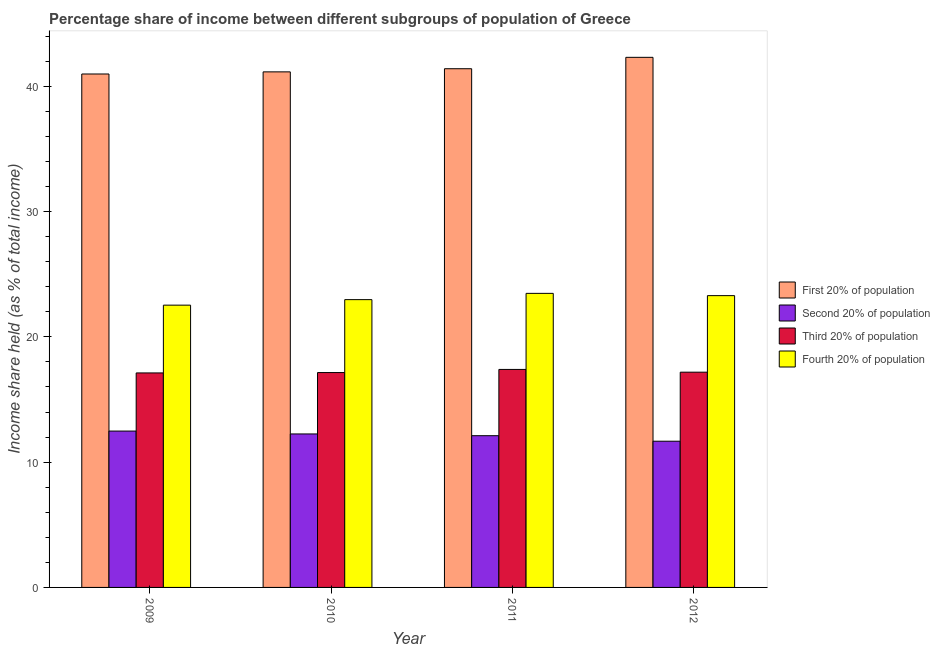How many bars are there on the 2nd tick from the left?
Your answer should be very brief. 4. How many bars are there on the 4th tick from the right?
Ensure brevity in your answer.  4. In how many cases, is the number of bars for a given year not equal to the number of legend labels?
Your answer should be compact. 0. What is the share of the income held by first 20% of the population in 2009?
Provide a succinct answer. 40.98. Across all years, what is the maximum share of the income held by fourth 20% of the population?
Offer a terse response. 23.47. Across all years, what is the minimum share of the income held by fourth 20% of the population?
Ensure brevity in your answer.  22.53. In which year was the share of the income held by third 20% of the population maximum?
Your answer should be compact. 2011. In which year was the share of the income held by fourth 20% of the population minimum?
Your response must be concise. 2009. What is the total share of the income held by fourth 20% of the population in the graph?
Make the answer very short. 92.26. What is the difference between the share of the income held by third 20% of the population in 2011 and that in 2012?
Provide a short and direct response. 0.22. What is the difference between the share of the income held by second 20% of the population in 2012 and the share of the income held by fourth 20% of the population in 2010?
Make the answer very short. -0.58. What is the average share of the income held by third 20% of the population per year?
Your response must be concise. 17.21. In the year 2011, what is the difference between the share of the income held by third 20% of the population and share of the income held by second 20% of the population?
Ensure brevity in your answer.  0. In how many years, is the share of the income held by second 20% of the population greater than 26 %?
Keep it short and to the point. 0. What is the ratio of the share of the income held by first 20% of the population in 2010 to that in 2012?
Provide a short and direct response. 0.97. What is the difference between the highest and the second highest share of the income held by second 20% of the population?
Keep it short and to the point. 0.23. What is the difference between the highest and the lowest share of the income held by third 20% of the population?
Keep it short and to the point. 0.28. Is it the case that in every year, the sum of the share of the income held by third 20% of the population and share of the income held by fourth 20% of the population is greater than the sum of share of the income held by first 20% of the population and share of the income held by second 20% of the population?
Give a very brief answer. No. What does the 3rd bar from the left in 2009 represents?
Make the answer very short. Third 20% of population. What does the 3rd bar from the right in 2012 represents?
Offer a terse response. Second 20% of population. How many bars are there?
Give a very brief answer. 16. How many years are there in the graph?
Give a very brief answer. 4. What is the difference between two consecutive major ticks on the Y-axis?
Offer a very short reply. 10. Are the values on the major ticks of Y-axis written in scientific E-notation?
Offer a very short reply. No. Where does the legend appear in the graph?
Make the answer very short. Center right. What is the title of the graph?
Give a very brief answer. Percentage share of income between different subgroups of population of Greece. Does "International Development Association" appear as one of the legend labels in the graph?
Offer a very short reply. No. What is the label or title of the X-axis?
Make the answer very short. Year. What is the label or title of the Y-axis?
Give a very brief answer. Income share held (as % of total income). What is the Income share held (as % of total income) in First 20% of population in 2009?
Provide a succinct answer. 40.98. What is the Income share held (as % of total income) of Second 20% of population in 2009?
Your response must be concise. 12.48. What is the Income share held (as % of total income) in Third 20% of population in 2009?
Give a very brief answer. 17.12. What is the Income share held (as % of total income) of Fourth 20% of population in 2009?
Give a very brief answer. 22.53. What is the Income share held (as % of total income) of First 20% of population in 2010?
Offer a very short reply. 41.15. What is the Income share held (as % of total income) in Second 20% of population in 2010?
Provide a succinct answer. 12.25. What is the Income share held (as % of total income) in Third 20% of population in 2010?
Ensure brevity in your answer.  17.15. What is the Income share held (as % of total income) of Fourth 20% of population in 2010?
Your answer should be very brief. 22.97. What is the Income share held (as % of total income) in First 20% of population in 2011?
Provide a short and direct response. 41.4. What is the Income share held (as % of total income) of Second 20% of population in 2011?
Give a very brief answer. 12.11. What is the Income share held (as % of total income) in Third 20% of population in 2011?
Make the answer very short. 17.4. What is the Income share held (as % of total income) of Fourth 20% of population in 2011?
Keep it short and to the point. 23.47. What is the Income share held (as % of total income) in First 20% of population in 2012?
Keep it short and to the point. 42.31. What is the Income share held (as % of total income) of Second 20% of population in 2012?
Give a very brief answer. 11.67. What is the Income share held (as % of total income) of Third 20% of population in 2012?
Offer a terse response. 17.18. What is the Income share held (as % of total income) of Fourth 20% of population in 2012?
Your response must be concise. 23.29. Across all years, what is the maximum Income share held (as % of total income) of First 20% of population?
Your answer should be compact. 42.31. Across all years, what is the maximum Income share held (as % of total income) in Second 20% of population?
Make the answer very short. 12.48. Across all years, what is the maximum Income share held (as % of total income) of Fourth 20% of population?
Your response must be concise. 23.47. Across all years, what is the minimum Income share held (as % of total income) of First 20% of population?
Give a very brief answer. 40.98. Across all years, what is the minimum Income share held (as % of total income) in Second 20% of population?
Keep it short and to the point. 11.67. Across all years, what is the minimum Income share held (as % of total income) in Third 20% of population?
Your response must be concise. 17.12. Across all years, what is the minimum Income share held (as % of total income) in Fourth 20% of population?
Provide a succinct answer. 22.53. What is the total Income share held (as % of total income) of First 20% of population in the graph?
Your answer should be very brief. 165.84. What is the total Income share held (as % of total income) in Second 20% of population in the graph?
Your response must be concise. 48.51. What is the total Income share held (as % of total income) of Third 20% of population in the graph?
Make the answer very short. 68.85. What is the total Income share held (as % of total income) of Fourth 20% of population in the graph?
Offer a terse response. 92.26. What is the difference between the Income share held (as % of total income) of First 20% of population in 2009 and that in 2010?
Keep it short and to the point. -0.17. What is the difference between the Income share held (as % of total income) in Second 20% of population in 2009 and that in 2010?
Provide a short and direct response. 0.23. What is the difference between the Income share held (as % of total income) in Third 20% of population in 2009 and that in 2010?
Ensure brevity in your answer.  -0.03. What is the difference between the Income share held (as % of total income) of Fourth 20% of population in 2009 and that in 2010?
Give a very brief answer. -0.44. What is the difference between the Income share held (as % of total income) in First 20% of population in 2009 and that in 2011?
Give a very brief answer. -0.42. What is the difference between the Income share held (as % of total income) in Second 20% of population in 2009 and that in 2011?
Your response must be concise. 0.37. What is the difference between the Income share held (as % of total income) of Third 20% of population in 2009 and that in 2011?
Offer a terse response. -0.28. What is the difference between the Income share held (as % of total income) in Fourth 20% of population in 2009 and that in 2011?
Provide a short and direct response. -0.94. What is the difference between the Income share held (as % of total income) of First 20% of population in 2009 and that in 2012?
Provide a succinct answer. -1.33. What is the difference between the Income share held (as % of total income) in Second 20% of population in 2009 and that in 2012?
Your answer should be very brief. 0.81. What is the difference between the Income share held (as % of total income) of Third 20% of population in 2009 and that in 2012?
Your response must be concise. -0.06. What is the difference between the Income share held (as % of total income) in Fourth 20% of population in 2009 and that in 2012?
Your response must be concise. -0.76. What is the difference between the Income share held (as % of total income) of First 20% of population in 2010 and that in 2011?
Offer a very short reply. -0.25. What is the difference between the Income share held (as % of total income) in Second 20% of population in 2010 and that in 2011?
Give a very brief answer. 0.14. What is the difference between the Income share held (as % of total income) in Third 20% of population in 2010 and that in 2011?
Your answer should be very brief. -0.25. What is the difference between the Income share held (as % of total income) of Fourth 20% of population in 2010 and that in 2011?
Your answer should be compact. -0.5. What is the difference between the Income share held (as % of total income) of First 20% of population in 2010 and that in 2012?
Offer a very short reply. -1.16. What is the difference between the Income share held (as % of total income) of Second 20% of population in 2010 and that in 2012?
Your response must be concise. 0.58. What is the difference between the Income share held (as % of total income) of Third 20% of population in 2010 and that in 2012?
Offer a very short reply. -0.03. What is the difference between the Income share held (as % of total income) of Fourth 20% of population in 2010 and that in 2012?
Your answer should be very brief. -0.32. What is the difference between the Income share held (as % of total income) of First 20% of population in 2011 and that in 2012?
Provide a succinct answer. -0.91. What is the difference between the Income share held (as % of total income) of Second 20% of population in 2011 and that in 2012?
Your response must be concise. 0.44. What is the difference between the Income share held (as % of total income) of Third 20% of population in 2011 and that in 2012?
Offer a terse response. 0.22. What is the difference between the Income share held (as % of total income) in Fourth 20% of population in 2011 and that in 2012?
Your response must be concise. 0.18. What is the difference between the Income share held (as % of total income) of First 20% of population in 2009 and the Income share held (as % of total income) of Second 20% of population in 2010?
Your answer should be very brief. 28.73. What is the difference between the Income share held (as % of total income) of First 20% of population in 2009 and the Income share held (as % of total income) of Third 20% of population in 2010?
Keep it short and to the point. 23.83. What is the difference between the Income share held (as % of total income) in First 20% of population in 2009 and the Income share held (as % of total income) in Fourth 20% of population in 2010?
Offer a very short reply. 18.01. What is the difference between the Income share held (as % of total income) in Second 20% of population in 2009 and the Income share held (as % of total income) in Third 20% of population in 2010?
Ensure brevity in your answer.  -4.67. What is the difference between the Income share held (as % of total income) in Second 20% of population in 2009 and the Income share held (as % of total income) in Fourth 20% of population in 2010?
Provide a short and direct response. -10.49. What is the difference between the Income share held (as % of total income) of Third 20% of population in 2009 and the Income share held (as % of total income) of Fourth 20% of population in 2010?
Provide a succinct answer. -5.85. What is the difference between the Income share held (as % of total income) in First 20% of population in 2009 and the Income share held (as % of total income) in Second 20% of population in 2011?
Keep it short and to the point. 28.87. What is the difference between the Income share held (as % of total income) of First 20% of population in 2009 and the Income share held (as % of total income) of Third 20% of population in 2011?
Your answer should be very brief. 23.58. What is the difference between the Income share held (as % of total income) in First 20% of population in 2009 and the Income share held (as % of total income) in Fourth 20% of population in 2011?
Provide a short and direct response. 17.51. What is the difference between the Income share held (as % of total income) in Second 20% of population in 2009 and the Income share held (as % of total income) in Third 20% of population in 2011?
Ensure brevity in your answer.  -4.92. What is the difference between the Income share held (as % of total income) in Second 20% of population in 2009 and the Income share held (as % of total income) in Fourth 20% of population in 2011?
Your response must be concise. -10.99. What is the difference between the Income share held (as % of total income) of Third 20% of population in 2009 and the Income share held (as % of total income) of Fourth 20% of population in 2011?
Your answer should be compact. -6.35. What is the difference between the Income share held (as % of total income) of First 20% of population in 2009 and the Income share held (as % of total income) of Second 20% of population in 2012?
Provide a short and direct response. 29.31. What is the difference between the Income share held (as % of total income) of First 20% of population in 2009 and the Income share held (as % of total income) of Third 20% of population in 2012?
Ensure brevity in your answer.  23.8. What is the difference between the Income share held (as % of total income) in First 20% of population in 2009 and the Income share held (as % of total income) in Fourth 20% of population in 2012?
Make the answer very short. 17.69. What is the difference between the Income share held (as % of total income) in Second 20% of population in 2009 and the Income share held (as % of total income) in Third 20% of population in 2012?
Your response must be concise. -4.7. What is the difference between the Income share held (as % of total income) of Second 20% of population in 2009 and the Income share held (as % of total income) of Fourth 20% of population in 2012?
Ensure brevity in your answer.  -10.81. What is the difference between the Income share held (as % of total income) in Third 20% of population in 2009 and the Income share held (as % of total income) in Fourth 20% of population in 2012?
Keep it short and to the point. -6.17. What is the difference between the Income share held (as % of total income) of First 20% of population in 2010 and the Income share held (as % of total income) of Second 20% of population in 2011?
Offer a very short reply. 29.04. What is the difference between the Income share held (as % of total income) of First 20% of population in 2010 and the Income share held (as % of total income) of Third 20% of population in 2011?
Make the answer very short. 23.75. What is the difference between the Income share held (as % of total income) in First 20% of population in 2010 and the Income share held (as % of total income) in Fourth 20% of population in 2011?
Provide a short and direct response. 17.68. What is the difference between the Income share held (as % of total income) in Second 20% of population in 2010 and the Income share held (as % of total income) in Third 20% of population in 2011?
Keep it short and to the point. -5.15. What is the difference between the Income share held (as % of total income) in Second 20% of population in 2010 and the Income share held (as % of total income) in Fourth 20% of population in 2011?
Provide a succinct answer. -11.22. What is the difference between the Income share held (as % of total income) in Third 20% of population in 2010 and the Income share held (as % of total income) in Fourth 20% of population in 2011?
Offer a terse response. -6.32. What is the difference between the Income share held (as % of total income) of First 20% of population in 2010 and the Income share held (as % of total income) of Second 20% of population in 2012?
Your answer should be compact. 29.48. What is the difference between the Income share held (as % of total income) of First 20% of population in 2010 and the Income share held (as % of total income) of Third 20% of population in 2012?
Provide a short and direct response. 23.97. What is the difference between the Income share held (as % of total income) of First 20% of population in 2010 and the Income share held (as % of total income) of Fourth 20% of population in 2012?
Provide a succinct answer. 17.86. What is the difference between the Income share held (as % of total income) in Second 20% of population in 2010 and the Income share held (as % of total income) in Third 20% of population in 2012?
Ensure brevity in your answer.  -4.93. What is the difference between the Income share held (as % of total income) in Second 20% of population in 2010 and the Income share held (as % of total income) in Fourth 20% of population in 2012?
Give a very brief answer. -11.04. What is the difference between the Income share held (as % of total income) of Third 20% of population in 2010 and the Income share held (as % of total income) of Fourth 20% of population in 2012?
Make the answer very short. -6.14. What is the difference between the Income share held (as % of total income) of First 20% of population in 2011 and the Income share held (as % of total income) of Second 20% of population in 2012?
Give a very brief answer. 29.73. What is the difference between the Income share held (as % of total income) of First 20% of population in 2011 and the Income share held (as % of total income) of Third 20% of population in 2012?
Provide a succinct answer. 24.22. What is the difference between the Income share held (as % of total income) of First 20% of population in 2011 and the Income share held (as % of total income) of Fourth 20% of population in 2012?
Give a very brief answer. 18.11. What is the difference between the Income share held (as % of total income) of Second 20% of population in 2011 and the Income share held (as % of total income) of Third 20% of population in 2012?
Offer a very short reply. -5.07. What is the difference between the Income share held (as % of total income) in Second 20% of population in 2011 and the Income share held (as % of total income) in Fourth 20% of population in 2012?
Provide a succinct answer. -11.18. What is the difference between the Income share held (as % of total income) in Third 20% of population in 2011 and the Income share held (as % of total income) in Fourth 20% of population in 2012?
Make the answer very short. -5.89. What is the average Income share held (as % of total income) in First 20% of population per year?
Ensure brevity in your answer.  41.46. What is the average Income share held (as % of total income) of Second 20% of population per year?
Make the answer very short. 12.13. What is the average Income share held (as % of total income) of Third 20% of population per year?
Give a very brief answer. 17.21. What is the average Income share held (as % of total income) in Fourth 20% of population per year?
Offer a very short reply. 23.07. In the year 2009, what is the difference between the Income share held (as % of total income) in First 20% of population and Income share held (as % of total income) in Second 20% of population?
Offer a terse response. 28.5. In the year 2009, what is the difference between the Income share held (as % of total income) of First 20% of population and Income share held (as % of total income) of Third 20% of population?
Keep it short and to the point. 23.86. In the year 2009, what is the difference between the Income share held (as % of total income) in First 20% of population and Income share held (as % of total income) in Fourth 20% of population?
Your answer should be compact. 18.45. In the year 2009, what is the difference between the Income share held (as % of total income) of Second 20% of population and Income share held (as % of total income) of Third 20% of population?
Provide a succinct answer. -4.64. In the year 2009, what is the difference between the Income share held (as % of total income) in Second 20% of population and Income share held (as % of total income) in Fourth 20% of population?
Your answer should be compact. -10.05. In the year 2009, what is the difference between the Income share held (as % of total income) of Third 20% of population and Income share held (as % of total income) of Fourth 20% of population?
Your answer should be very brief. -5.41. In the year 2010, what is the difference between the Income share held (as % of total income) of First 20% of population and Income share held (as % of total income) of Second 20% of population?
Your answer should be very brief. 28.9. In the year 2010, what is the difference between the Income share held (as % of total income) in First 20% of population and Income share held (as % of total income) in Third 20% of population?
Ensure brevity in your answer.  24. In the year 2010, what is the difference between the Income share held (as % of total income) of First 20% of population and Income share held (as % of total income) of Fourth 20% of population?
Ensure brevity in your answer.  18.18. In the year 2010, what is the difference between the Income share held (as % of total income) of Second 20% of population and Income share held (as % of total income) of Third 20% of population?
Offer a terse response. -4.9. In the year 2010, what is the difference between the Income share held (as % of total income) in Second 20% of population and Income share held (as % of total income) in Fourth 20% of population?
Provide a short and direct response. -10.72. In the year 2010, what is the difference between the Income share held (as % of total income) of Third 20% of population and Income share held (as % of total income) of Fourth 20% of population?
Offer a terse response. -5.82. In the year 2011, what is the difference between the Income share held (as % of total income) of First 20% of population and Income share held (as % of total income) of Second 20% of population?
Ensure brevity in your answer.  29.29. In the year 2011, what is the difference between the Income share held (as % of total income) of First 20% of population and Income share held (as % of total income) of Fourth 20% of population?
Provide a short and direct response. 17.93. In the year 2011, what is the difference between the Income share held (as % of total income) in Second 20% of population and Income share held (as % of total income) in Third 20% of population?
Your response must be concise. -5.29. In the year 2011, what is the difference between the Income share held (as % of total income) of Second 20% of population and Income share held (as % of total income) of Fourth 20% of population?
Your answer should be compact. -11.36. In the year 2011, what is the difference between the Income share held (as % of total income) in Third 20% of population and Income share held (as % of total income) in Fourth 20% of population?
Provide a short and direct response. -6.07. In the year 2012, what is the difference between the Income share held (as % of total income) in First 20% of population and Income share held (as % of total income) in Second 20% of population?
Offer a very short reply. 30.64. In the year 2012, what is the difference between the Income share held (as % of total income) of First 20% of population and Income share held (as % of total income) of Third 20% of population?
Provide a succinct answer. 25.13. In the year 2012, what is the difference between the Income share held (as % of total income) of First 20% of population and Income share held (as % of total income) of Fourth 20% of population?
Your answer should be compact. 19.02. In the year 2012, what is the difference between the Income share held (as % of total income) in Second 20% of population and Income share held (as % of total income) in Third 20% of population?
Give a very brief answer. -5.51. In the year 2012, what is the difference between the Income share held (as % of total income) in Second 20% of population and Income share held (as % of total income) in Fourth 20% of population?
Your response must be concise. -11.62. In the year 2012, what is the difference between the Income share held (as % of total income) of Third 20% of population and Income share held (as % of total income) of Fourth 20% of population?
Offer a terse response. -6.11. What is the ratio of the Income share held (as % of total income) in Second 20% of population in 2009 to that in 2010?
Provide a succinct answer. 1.02. What is the ratio of the Income share held (as % of total income) in Third 20% of population in 2009 to that in 2010?
Keep it short and to the point. 1. What is the ratio of the Income share held (as % of total income) of Fourth 20% of population in 2009 to that in 2010?
Your answer should be very brief. 0.98. What is the ratio of the Income share held (as % of total income) in First 20% of population in 2009 to that in 2011?
Give a very brief answer. 0.99. What is the ratio of the Income share held (as % of total income) of Second 20% of population in 2009 to that in 2011?
Offer a very short reply. 1.03. What is the ratio of the Income share held (as % of total income) of Third 20% of population in 2009 to that in 2011?
Provide a succinct answer. 0.98. What is the ratio of the Income share held (as % of total income) in Fourth 20% of population in 2009 to that in 2011?
Provide a short and direct response. 0.96. What is the ratio of the Income share held (as % of total income) in First 20% of population in 2009 to that in 2012?
Your response must be concise. 0.97. What is the ratio of the Income share held (as % of total income) in Second 20% of population in 2009 to that in 2012?
Give a very brief answer. 1.07. What is the ratio of the Income share held (as % of total income) in Fourth 20% of population in 2009 to that in 2012?
Your response must be concise. 0.97. What is the ratio of the Income share held (as % of total income) in Second 20% of population in 2010 to that in 2011?
Offer a very short reply. 1.01. What is the ratio of the Income share held (as % of total income) in Third 20% of population in 2010 to that in 2011?
Offer a very short reply. 0.99. What is the ratio of the Income share held (as % of total income) in Fourth 20% of population in 2010 to that in 2011?
Offer a very short reply. 0.98. What is the ratio of the Income share held (as % of total income) of First 20% of population in 2010 to that in 2012?
Keep it short and to the point. 0.97. What is the ratio of the Income share held (as % of total income) in Second 20% of population in 2010 to that in 2012?
Your answer should be very brief. 1.05. What is the ratio of the Income share held (as % of total income) in Fourth 20% of population in 2010 to that in 2012?
Your response must be concise. 0.99. What is the ratio of the Income share held (as % of total income) in First 20% of population in 2011 to that in 2012?
Ensure brevity in your answer.  0.98. What is the ratio of the Income share held (as % of total income) in Second 20% of population in 2011 to that in 2012?
Your response must be concise. 1.04. What is the ratio of the Income share held (as % of total income) in Third 20% of population in 2011 to that in 2012?
Give a very brief answer. 1.01. What is the ratio of the Income share held (as % of total income) in Fourth 20% of population in 2011 to that in 2012?
Your answer should be very brief. 1.01. What is the difference between the highest and the second highest Income share held (as % of total income) in First 20% of population?
Your response must be concise. 0.91. What is the difference between the highest and the second highest Income share held (as % of total income) of Second 20% of population?
Your answer should be very brief. 0.23. What is the difference between the highest and the second highest Income share held (as % of total income) of Third 20% of population?
Give a very brief answer. 0.22. What is the difference between the highest and the second highest Income share held (as % of total income) in Fourth 20% of population?
Keep it short and to the point. 0.18. What is the difference between the highest and the lowest Income share held (as % of total income) of First 20% of population?
Your response must be concise. 1.33. What is the difference between the highest and the lowest Income share held (as % of total income) of Second 20% of population?
Make the answer very short. 0.81. What is the difference between the highest and the lowest Income share held (as % of total income) in Third 20% of population?
Provide a short and direct response. 0.28. What is the difference between the highest and the lowest Income share held (as % of total income) of Fourth 20% of population?
Give a very brief answer. 0.94. 